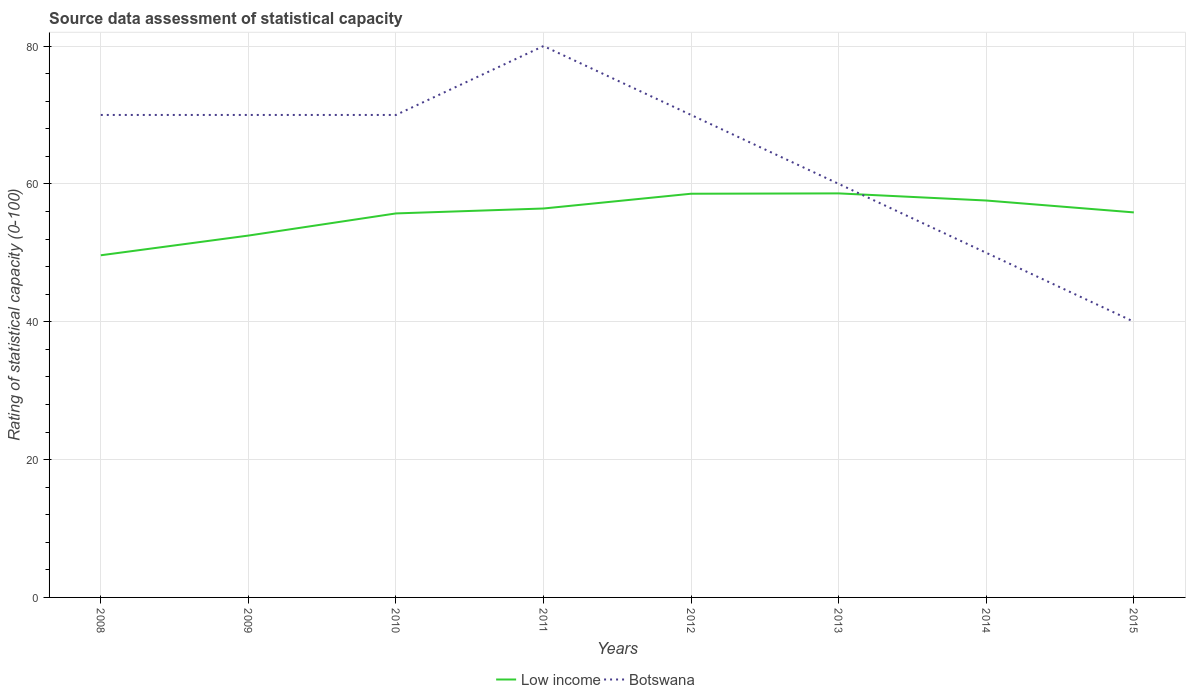How many different coloured lines are there?
Your response must be concise. 2. Does the line corresponding to Low income intersect with the line corresponding to Botswana?
Your response must be concise. Yes. Is the number of lines equal to the number of legend labels?
Offer a very short reply. Yes. Across all years, what is the maximum rating of statistical capacity in Botswana?
Ensure brevity in your answer.  40. In which year was the rating of statistical capacity in Botswana maximum?
Keep it short and to the point. 2015. What is the total rating of statistical capacity in Botswana in the graph?
Your answer should be very brief. 10. What is the difference between the highest and the second highest rating of statistical capacity in Low income?
Provide a succinct answer. 8.98. What is the difference between the highest and the lowest rating of statistical capacity in Botswana?
Your response must be concise. 5. Is the rating of statistical capacity in Botswana strictly greater than the rating of statistical capacity in Low income over the years?
Provide a short and direct response. No. What is the difference between two consecutive major ticks on the Y-axis?
Provide a succinct answer. 20. Does the graph contain any zero values?
Provide a succinct answer. No. Does the graph contain grids?
Make the answer very short. Yes. Where does the legend appear in the graph?
Give a very brief answer. Bottom center. What is the title of the graph?
Keep it short and to the point. Source data assessment of statistical capacity. What is the label or title of the Y-axis?
Ensure brevity in your answer.  Rating of statistical capacity (0-100). What is the Rating of statistical capacity (0-100) in Low income in 2008?
Your response must be concise. 49.64. What is the Rating of statistical capacity (0-100) of Low income in 2009?
Provide a succinct answer. 52.5. What is the Rating of statistical capacity (0-100) in Botswana in 2009?
Make the answer very short. 70. What is the Rating of statistical capacity (0-100) of Low income in 2010?
Give a very brief answer. 55.71. What is the Rating of statistical capacity (0-100) of Low income in 2011?
Offer a terse response. 56.43. What is the Rating of statistical capacity (0-100) in Botswana in 2011?
Keep it short and to the point. 80. What is the Rating of statistical capacity (0-100) in Low income in 2012?
Provide a short and direct response. 58.57. What is the Rating of statistical capacity (0-100) in Botswana in 2012?
Your answer should be very brief. 70. What is the Rating of statistical capacity (0-100) in Low income in 2013?
Ensure brevity in your answer.  58.62. What is the Rating of statistical capacity (0-100) in Low income in 2014?
Keep it short and to the point. 57.59. What is the Rating of statistical capacity (0-100) in Low income in 2015?
Give a very brief answer. 55.86. What is the Rating of statistical capacity (0-100) of Botswana in 2015?
Give a very brief answer. 40. Across all years, what is the maximum Rating of statistical capacity (0-100) of Low income?
Ensure brevity in your answer.  58.62. Across all years, what is the minimum Rating of statistical capacity (0-100) of Low income?
Provide a short and direct response. 49.64. What is the total Rating of statistical capacity (0-100) in Low income in the graph?
Provide a succinct answer. 444.93. What is the total Rating of statistical capacity (0-100) of Botswana in the graph?
Keep it short and to the point. 510. What is the difference between the Rating of statistical capacity (0-100) in Low income in 2008 and that in 2009?
Provide a succinct answer. -2.86. What is the difference between the Rating of statistical capacity (0-100) of Low income in 2008 and that in 2010?
Provide a succinct answer. -6.07. What is the difference between the Rating of statistical capacity (0-100) of Low income in 2008 and that in 2011?
Your answer should be compact. -6.79. What is the difference between the Rating of statistical capacity (0-100) in Botswana in 2008 and that in 2011?
Make the answer very short. -10. What is the difference between the Rating of statistical capacity (0-100) of Low income in 2008 and that in 2012?
Provide a succinct answer. -8.93. What is the difference between the Rating of statistical capacity (0-100) of Botswana in 2008 and that in 2012?
Provide a short and direct response. 0. What is the difference between the Rating of statistical capacity (0-100) of Low income in 2008 and that in 2013?
Ensure brevity in your answer.  -8.98. What is the difference between the Rating of statistical capacity (0-100) of Low income in 2008 and that in 2014?
Your answer should be compact. -7.94. What is the difference between the Rating of statistical capacity (0-100) in Botswana in 2008 and that in 2014?
Offer a terse response. 20. What is the difference between the Rating of statistical capacity (0-100) in Low income in 2008 and that in 2015?
Your answer should be very brief. -6.22. What is the difference between the Rating of statistical capacity (0-100) of Low income in 2009 and that in 2010?
Provide a short and direct response. -3.21. What is the difference between the Rating of statistical capacity (0-100) in Botswana in 2009 and that in 2010?
Offer a terse response. 0. What is the difference between the Rating of statistical capacity (0-100) of Low income in 2009 and that in 2011?
Offer a very short reply. -3.93. What is the difference between the Rating of statistical capacity (0-100) of Botswana in 2009 and that in 2011?
Make the answer very short. -10. What is the difference between the Rating of statistical capacity (0-100) of Low income in 2009 and that in 2012?
Your answer should be very brief. -6.07. What is the difference between the Rating of statistical capacity (0-100) of Botswana in 2009 and that in 2012?
Your answer should be very brief. 0. What is the difference between the Rating of statistical capacity (0-100) in Low income in 2009 and that in 2013?
Make the answer very short. -6.12. What is the difference between the Rating of statistical capacity (0-100) of Botswana in 2009 and that in 2013?
Offer a terse response. 10. What is the difference between the Rating of statistical capacity (0-100) of Low income in 2009 and that in 2014?
Keep it short and to the point. -5.09. What is the difference between the Rating of statistical capacity (0-100) of Low income in 2009 and that in 2015?
Your answer should be very brief. -3.36. What is the difference between the Rating of statistical capacity (0-100) of Botswana in 2009 and that in 2015?
Give a very brief answer. 30. What is the difference between the Rating of statistical capacity (0-100) in Low income in 2010 and that in 2011?
Keep it short and to the point. -0.71. What is the difference between the Rating of statistical capacity (0-100) in Low income in 2010 and that in 2012?
Keep it short and to the point. -2.86. What is the difference between the Rating of statistical capacity (0-100) of Botswana in 2010 and that in 2012?
Your response must be concise. 0. What is the difference between the Rating of statistical capacity (0-100) in Low income in 2010 and that in 2013?
Keep it short and to the point. -2.91. What is the difference between the Rating of statistical capacity (0-100) of Low income in 2010 and that in 2014?
Your response must be concise. -1.87. What is the difference between the Rating of statistical capacity (0-100) of Low income in 2010 and that in 2015?
Your answer should be compact. -0.15. What is the difference between the Rating of statistical capacity (0-100) of Low income in 2011 and that in 2012?
Your response must be concise. -2.14. What is the difference between the Rating of statistical capacity (0-100) in Botswana in 2011 and that in 2012?
Offer a very short reply. 10. What is the difference between the Rating of statistical capacity (0-100) of Low income in 2011 and that in 2013?
Offer a very short reply. -2.19. What is the difference between the Rating of statistical capacity (0-100) in Botswana in 2011 and that in 2013?
Provide a short and direct response. 20. What is the difference between the Rating of statistical capacity (0-100) in Low income in 2011 and that in 2014?
Provide a short and direct response. -1.16. What is the difference between the Rating of statistical capacity (0-100) of Botswana in 2011 and that in 2014?
Your answer should be compact. 30. What is the difference between the Rating of statistical capacity (0-100) of Low income in 2011 and that in 2015?
Ensure brevity in your answer.  0.57. What is the difference between the Rating of statistical capacity (0-100) of Low income in 2012 and that in 2013?
Ensure brevity in your answer.  -0.05. What is the difference between the Rating of statistical capacity (0-100) of Botswana in 2012 and that in 2013?
Offer a very short reply. 10. What is the difference between the Rating of statistical capacity (0-100) of Low income in 2012 and that in 2014?
Give a very brief answer. 0.99. What is the difference between the Rating of statistical capacity (0-100) of Low income in 2012 and that in 2015?
Your answer should be very brief. 2.71. What is the difference between the Rating of statistical capacity (0-100) of Botswana in 2012 and that in 2015?
Offer a terse response. 30. What is the difference between the Rating of statistical capacity (0-100) in Low income in 2013 and that in 2014?
Ensure brevity in your answer.  1.03. What is the difference between the Rating of statistical capacity (0-100) in Botswana in 2013 and that in 2014?
Ensure brevity in your answer.  10. What is the difference between the Rating of statistical capacity (0-100) of Low income in 2013 and that in 2015?
Your answer should be compact. 2.76. What is the difference between the Rating of statistical capacity (0-100) of Low income in 2014 and that in 2015?
Give a very brief answer. 1.72. What is the difference between the Rating of statistical capacity (0-100) in Low income in 2008 and the Rating of statistical capacity (0-100) in Botswana in 2009?
Your answer should be very brief. -20.36. What is the difference between the Rating of statistical capacity (0-100) in Low income in 2008 and the Rating of statistical capacity (0-100) in Botswana in 2010?
Give a very brief answer. -20.36. What is the difference between the Rating of statistical capacity (0-100) in Low income in 2008 and the Rating of statistical capacity (0-100) in Botswana in 2011?
Your answer should be compact. -30.36. What is the difference between the Rating of statistical capacity (0-100) of Low income in 2008 and the Rating of statistical capacity (0-100) of Botswana in 2012?
Your answer should be compact. -20.36. What is the difference between the Rating of statistical capacity (0-100) of Low income in 2008 and the Rating of statistical capacity (0-100) of Botswana in 2013?
Give a very brief answer. -10.36. What is the difference between the Rating of statistical capacity (0-100) of Low income in 2008 and the Rating of statistical capacity (0-100) of Botswana in 2014?
Make the answer very short. -0.36. What is the difference between the Rating of statistical capacity (0-100) of Low income in 2008 and the Rating of statistical capacity (0-100) of Botswana in 2015?
Your response must be concise. 9.64. What is the difference between the Rating of statistical capacity (0-100) in Low income in 2009 and the Rating of statistical capacity (0-100) in Botswana in 2010?
Your response must be concise. -17.5. What is the difference between the Rating of statistical capacity (0-100) in Low income in 2009 and the Rating of statistical capacity (0-100) in Botswana in 2011?
Your answer should be very brief. -27.5. What is the difference between the Rating of statistical capacity (0-100) of Low income in 2009 and the Rating of statistical capacity (0-100) of Botswana in 2012?
Provide a short and direct response. -17.5. What is the difference between the Rating of statistical capacity (0-100) in Low income in 2009 and the Rating of statistical capacity (0-100) in Botswana in 2013?
Your answer should be compact. -7.5. What is the difference between the Rating of statistical capacity (0-100) of Low income in 2009 and the Rating of statistical capacity (0-100) of Botswana in 2015?
Your response must be concise. 12.5. What is the difference between the Rating of statistical capacity (0-100) of Low income in 2010 and the Rating of statistical capacity (0-100) of Botswana in 2011?
Ensure brevity in your answer.  -24.29. What is the difference between the Rating of statistical capacity (0-100) in Low income in 2010 and the Rating of statistical capacity (0-100) in Botswana in 2012?
Provide a succinct answer. -14.29. What is the difference between the Rating of statistical capacity (0-100) of Low income in 2010 and the Rating of statistical capacity (0-100) of Botswana in 2013?
Offer a very short reply. -4.29. What is the difference between the Rating of statistical capacity (0-100) of Low income in 2010 and the Rating of statistical capacity (0-100) of Botswana in 2014?
Offer a very short reply. 5.71. What is the difference between the Rating of statistical capacity (0-100) of Low income in 2010 and the Rating of statistical capacity (0-100) of Botswana in 2015?
Offer a terse response. 15.71. What is the difference between the Rating of statistical capacity (0-100) of Low income in 2011 and the Rating of statistical capacity (0-100) of Botswana in 2012?
Ensure brevity in your answer.  -13.57. What is the difference between the Rating of statistical capacity (0-100) in Low income in 2011 and the Rating of statistical capacity (0-100) in Botswana in 2013?
Provide a short and direct response. -3.57. What is the difference between the Rating of statistical capacity (0-100) in Low income in 2011 and the Rating of statistical capacity (0-100) in Botswana in 2014?
Your answer should be very brief. 6.43. What is the difference between the Rating of statistical capacity (0-100) of Low income in 2011 and the Rating of statistical capacity (0-100) of Botswana in 2015?
Provide a short and direct response. 16.43. What is the difference between the Rating of statistical capacity (0-100) in Low income in 2012 and the Rating of statistical capacity (0-100) in Botswana in 2013?
Provide a succinct answer. -1.43. What is the difference between the Rating of statistical capacity (0-100) of Low income in 2012 and the Rating of statistical capacity (0-100) of Botswana in 2014?
Provide a succinct answer. 8.57. What is the difference between the Rating of statistical capacity (0-100) in Low income in 2012 and the Rating of statistical capacity (0-100) in Botswana in 2015?
Keep it short and to the point. 18.57. What is the difference between the Rating of statistical capacity (0-100) in Low income in 2013 and the Rating of statistical capacity (0-100) in Botswana in 2014?
Offer a terse response. 8.62. What is the difference between the Rating of statistical capacity (0-100) of Low income in 2013 and the Rating of statistical capacity (0-100) of Botswana in 2015?
Provide a short and direct response. 18.62. What is the difference between the Rating of statistical capacity (0-100) of Low income in 2014 and the Rating of statistical capacity (0-100) of Botswana in 2015?
Keep it short and to the point. 17.59. What is the average Rating of statistical capacity (0-100) of Low income per year?
Your answer should be very brief. 55.62. What is the average Rating of statistical capacity (0-100) of Botswana per year?
Make the answer very short. 63.75. In the year 2008, what is the difference between the Rating of statistical capacity (0-100) of Low income and Rating of statistical capacity (0-100) of Botswana?
Give a very brief answer. -20.36. In the year 2009, what is the difference between the Rating of statistical capacity (0-100) of Low income and Rating of statistical capacity (0-100) of Botswana?
Keep it short and to the point. -17.5. In the year 2010, what is the difference between the Rating of statistical capacity (0-100) in Low income and Rating of statistical capacity (0-100) in Botswana?
Provide a succinct answer. -14.29. In the year 2011, what is the difference between the Rating of statistical capacity (0-100) in Low income and Rating of statistical capacity (0-100) in Botswana?
Your answer should be very brief. -23.57. In the year 2012, what is the difference between the Rating of statistical capacity (0-100) in Low income and Rating of statistical capacity (0-100) in Botswana?
Keep it short and to the point. -11.43. In the year 2013, what is the difference between the Rating of statistical capacity (0-100) of Low income and Rating of statistical capacity (0-100) of Botswana?
Your response must be concise. -1.38. In the year 2014, what is the difference between the Rating of statistical capacity (0-100) of Low income and Rating of statistical capacity (0-100) of Botswana?
Keep it short and to the point. 7.59. In the year 2015, what is the difference between the Rating of statistical capacity (0-100) of Low income and Rating of statistical capacity (0-100) of Botswana?
Your answer should be compact. 15.86. What is the ratio of the Rating of statistical capacity (0-100) of Low income in 2008 to that in 2009?
Your answer should be very brief. 0.95. What is the ratio of the Rating of statistical capacity (0-100) of Botswana in 2008 to that in 2009?
Your answer should be compact. 1. What is the ratio of the Rating of statistical capacity (0-100) of Low income in 2008 to that in 2010?
Ensure brevity in your answer.  0.89. What is the ratio of the Rating of statistical capacity (0-100) of Botswana in 2008 to that in 2010?
Provide a short and direct response. 1. What is the ratio of the Rating of statistical capacity (0-100) in Low income in 2008 to that in 2011?
Give a very brief answer. 0.88. What is the ratio of the Rating of statistical capacity (0-100) of Low income in 2008 to that in 2012?
Keep it short and to the point. 0.85. What is the ratio of the Rating of statistical capacity (0-100) in Botswana in 2008 to that in 2012?
Give a very brief answer. 1. What is the ratio of the Rating of statistical capacity (0-100) in Low income in 2008 to that in 2013?
Ensure brevity in your answer.  0.85. What is the ratio of the Rating of statistical capacity (0-100) of Low income in 2008 to that in 2014?
Make the answer very short. 0.86. What is the ratio of the Rating of statistical capacity (0-100) of Low income in 2008 to that in 2015?
Keep it short and to the point. 0.89. What is the ratio of the Rating of statistical capacity (0-100) of Low income in 2009 to that in 2010?
Make the answer very short. 0.94. What is the ratio of the Rating of statistical capacity (0-100) in Botswana in 2009 to that in 2010?
Your response must be concise. 1. What is the ratio of the Rating of statistical capacity (0-100) in Low income in 2009 to that in 2011?
Offer a terse response. 0.93. What is the ratio of the Rating of statistical capacity (0-100) of Botswana in 2009 to that in 2011?
Keep it short and to the point. 0.88. What is the ratio of the Rating of statistical capacity (0-100) of Low income in 2009 to that in 2012?
Make the answer very short. 0.9. What is the ratio of the Rating of statistical capacity (0-100) in Low income in 2009 to that in 2013?
Your answer should be compact. 0.9. What is the ratio of the Rating of statistical capacity (0-100) of Botswana in 2009 to that in 2013?
Your response must be concise. 1.17. What is the ratio of the Rating of statistical capacity (0-100) of Low income in 2009 to that in 2014?
Your answer should be compact. 0.91. What is the ratio of the Rating of statistical capacity (0-100) of Low income in 2009 to that in 2015?
Offer a terse response. 0.94. What is the ratio of the Rating of statistical capacity (0-100) in Low income in 2010 to that in 2011?
Your answer should be compact. 0.99. What is the ratio of the Rating of statistical capacity (0-100) of Low income in 2010 to that in 2012?
Offer a terse response. 0.95. What is the ratio of the Rating of statistical capacity (0-100) in Low income in 2010 to that in 2013?
Give a very brief answer. 0.95. What is the ratio of the Rating of statistical capacity (0-100) in Botswana in 2010 to that in 2013?
Ensure brevity in your answer.  1.17. What is the ratio of the Rating of statistical capacity (0-100) of Low income in 2010 to that in 2014?
Ensure brevity in your answer.  0.97. What is the ratio of the Rating of statistical capacity (0-100) of Botswana in 2010 to that in 2014?
Offer a very short reply. 1.4. What is the ratio of the Rating of statistical capacity (0-100) in Botswana in 2010 to that in 2015?
Provide a short and direct response. 1.75. What is the ratio of the Rating of statistical capacity (0-100) in Low income in 2011 to that in 2012?
Make the answer very short. 0.96. What is the ratio of the Rating of statistical capacity (0-100) of Botswana in 2011 to that in 2012?
Offer a very short reply. 1.14. What is the ratio of the Rating of statistical capacity (0-100) of Low income in 2011 to that in 2013?
Your response must be concise. 0.96. What is the ratio of the Rating of statistical capacity (0-100) in Botswana in 2011 to that in 2013?
Offer a terse response. 1.33. What is the ratio of the Rating of statistical capacity (0-100) of Low income in 2011 to that in 2014?
Provide a short and direct response. 0.98. What is the ratio of the Rating of statistical capacity (0-100) of Low income in 2011 to that in 2015?
Keep it short and to the point. 1.01. What is the ratio of the Rating of statistical capacity (0-100) of Botswana in 2011 to that in 2015?
Offer a very short reply. 2. What is the ratio of the Rating of statistical capacity (0-100) in Low income in 2012 to that in 2014?
Offer a very short reply. 1.02. What is the ratio of the Rating of statistical capacity (0-100) in Low income in 2012 to that in 2015?
Provide a short and direct response. 1.05. What is the ratio of the Rating of statistical capacity (0-100) in Botswana in 2013 to that in 2014?
Provide a short and direct response. 1.2. What is the ratio of the Rating of statistical capacity (0-100) of Low income in 2013 to that in 2015?
Ensure brevity in your answer.  1.05. What is the ratio of the Rating of statistical capacity (0-100) of Low income in 2014 to that in 2015?
Offer a very short reply. 1.03. What is the ratio of the Rating of statistical capacity (0-100) in Botswana in 2014 to that in 2015?
Keep it short and to the point. 1.25. What is the difference between the highest and the second highest Rating of statistical capacity (0-100) of Low income?
Keep it short and to the point. 0.05. What is the difference between the highest and the second highest Rating of statistical capacity (0-100) in Botswana?
Provide a succinct answer. 10. What is the difference between the highest and the lowest Rating of statistical capacity (0-100) in Low income?
Offer a very short reply. 8.98. 